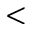Convert formula to latex. <formula><loc_0><loc_0><loc_500><loc_500><</formula> 